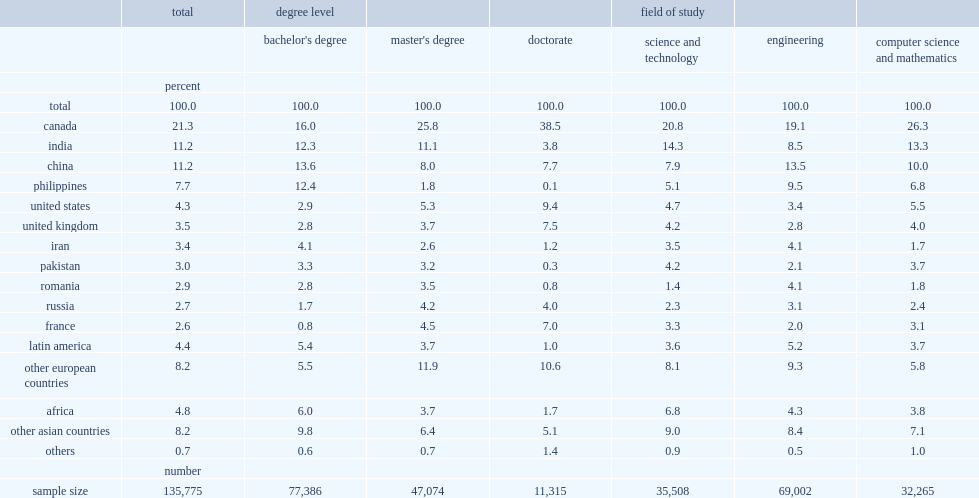What percent of stem bachelor's degree holders were educated in canada, the united states, the united kingdom or france? 22.5. What percent of master's degree holders were educated in canada, the united states, the united kingdom or france? 39.3. What percent of doctorate were educated in canada, the united states, the united kingdom, or france? 62.4. 